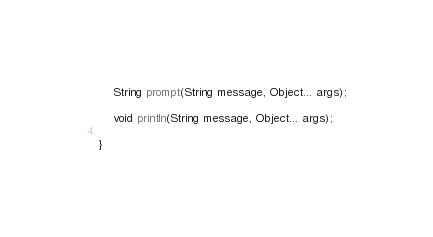Convert code to text. <code><loc_0><loc_0><loc_500><loc_500><_Java_>
	String prompt(String message, Object... args);

	void println(String message, Object... args);

}
</code> 